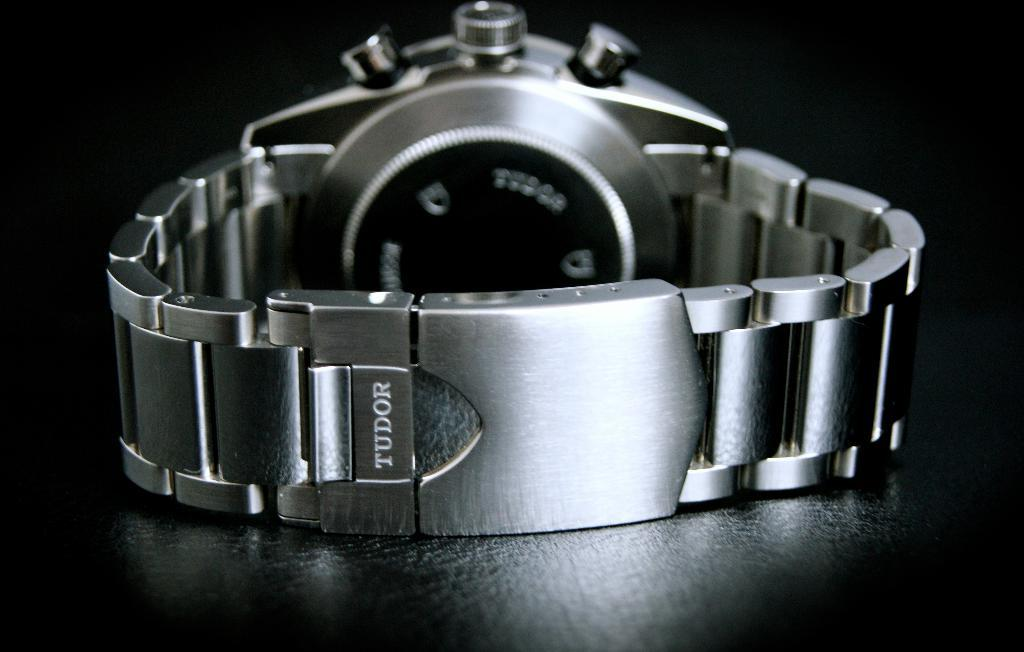<image>
Write a terse but informative summary of the picture. Silver watch made by Tudor laying on a dark wood table. 